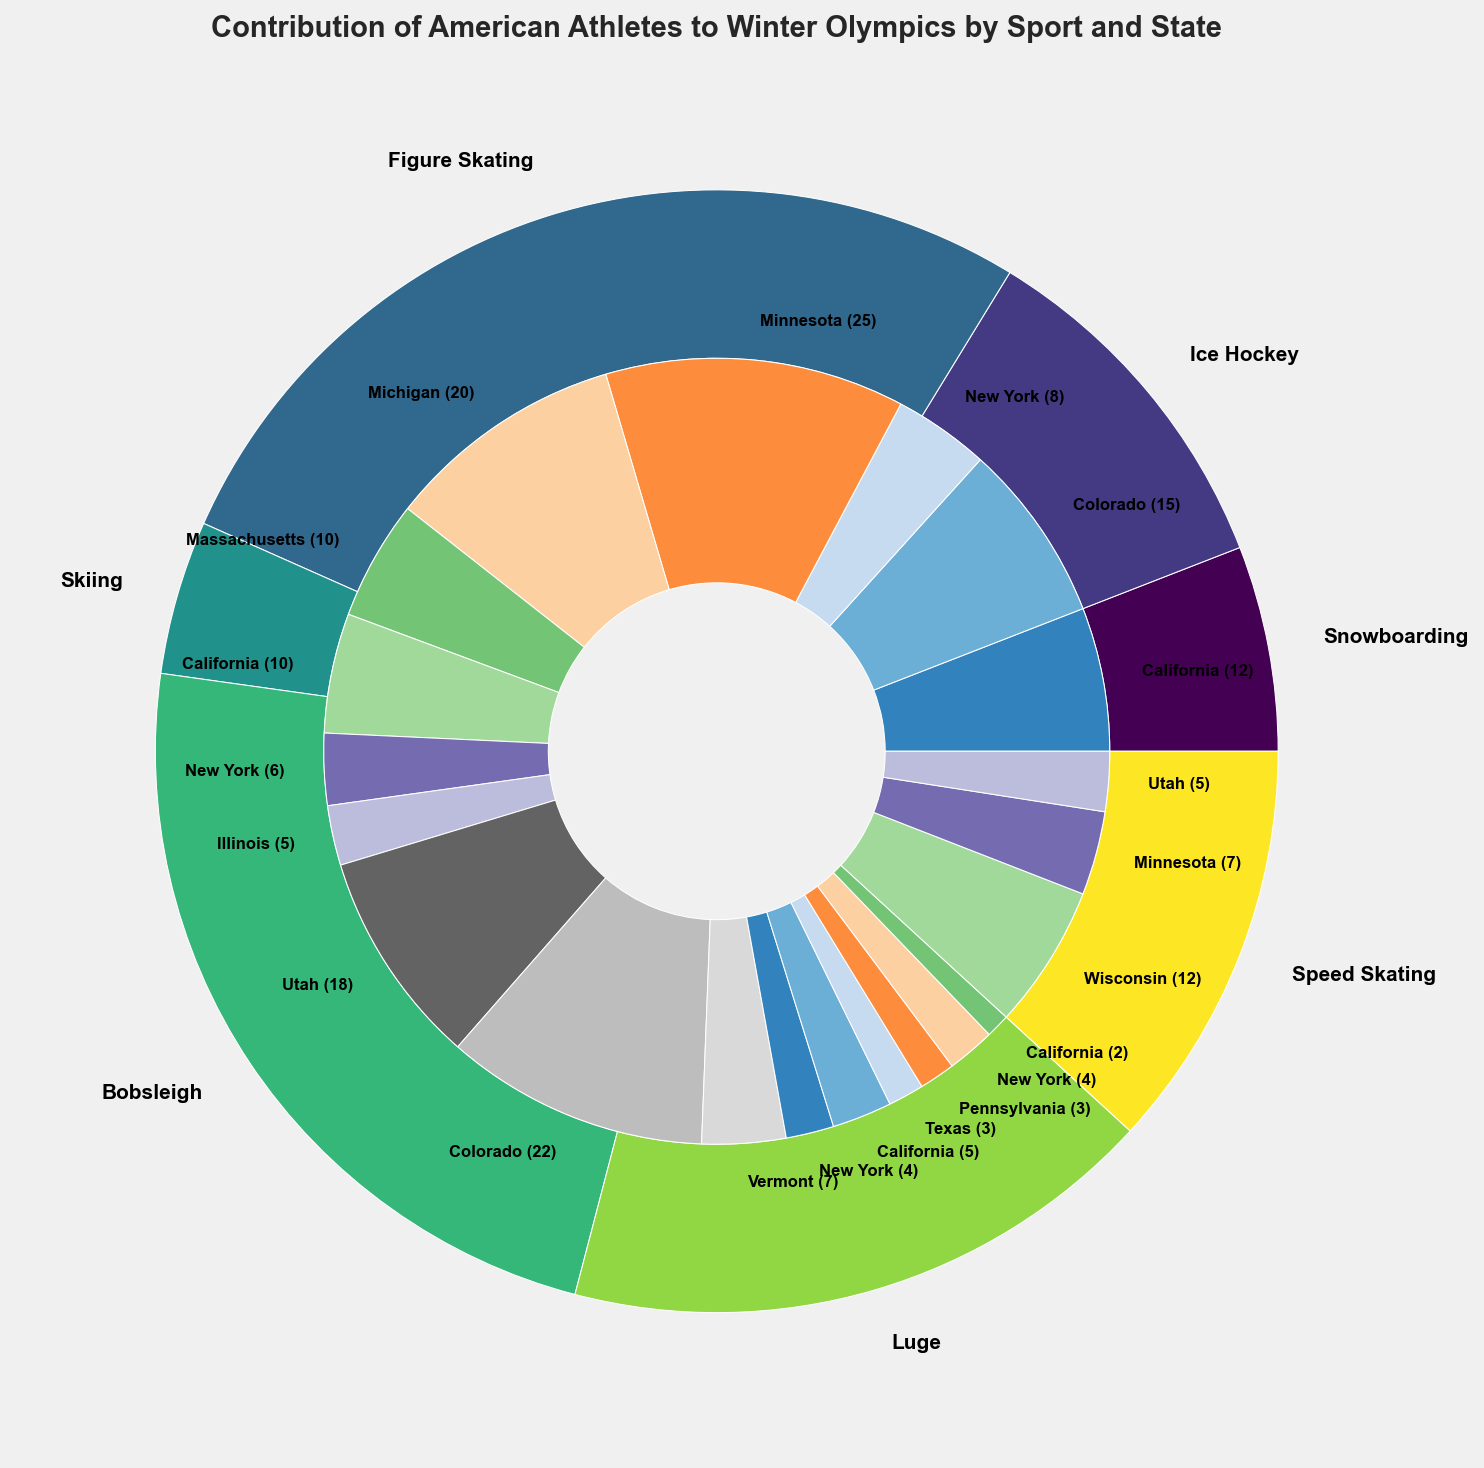Which state has the highest contribution in Ice Hockey? Minnesota's segment within the Ice Hockey section is the largest compared to other states' segments.
Answer: Minnesota How many athletes in total are from California contributing across all sports? Identify all segments from California in the inner pie: Snowboarding (12), Figure Skating (10), Bobsleigh (5), Luge (2). Sum them up (12 + 10 + 5 + 2).
Answer: 29 Which sport has the most diverse state representation, and which states are included? The sport with the most differently colored segments in the inner circle is Skiing. The states contributing to Skiing are Utah, Colorado, and Vermont.
Answer: Skiing with Utah, Colorado, Vermont Compare the number of athletes from New York in Snowboarding and Bobsleigh. By how much does the number differ? Locate New York's segments in Snowboarding (8) and Bobsleigh (4). Calculate the difference (8 - 4).
Answer: 4 What is the total number of athletes from states starting with "C"? Identify all segments from California (12 + 10 + 5 + 2) and Colorado (15 + 22) in the inner pie. Sum them up (12 + 10 + 5 + 2 + 15 + 22).
Answer: 66 Which sport has the smallest contribution from a single state, and how many athletes does that state contribute? The smallest single segment in the inner pie is from Texas in Bobsleigh with 3 athletes.
Answer: 3 athletes from Texas for Bobsleigh Among Speed Skating athletes, which state has the second-highest contribution? For Speed Skating, the largest segment is from Wisconsin, and the second largest segment is from Minnesota.
Answer: Minnesota How many athletes contribute to the Winter Olympics from the states in the Northeast region (New York, Pennsylvania, Massachusetts, Vermont)? Locate all segments from New York, Pennsylvania, Massachusetts, and Vermont in the inner pie. Add athletes from each of these states: NY (8 + 6 + 4), PA (3), MA (10), VT (7). Sum them all (8 + 6 + 4 + 3 + 10 + 7).
Answer: 38 In Figure Skating, which state has the least number of athletes, and what is that number? Identify the smallest segment in the Figure Skating section; it's Illinois with 5 athletes.
Answer: Illinois with 5 athletes 